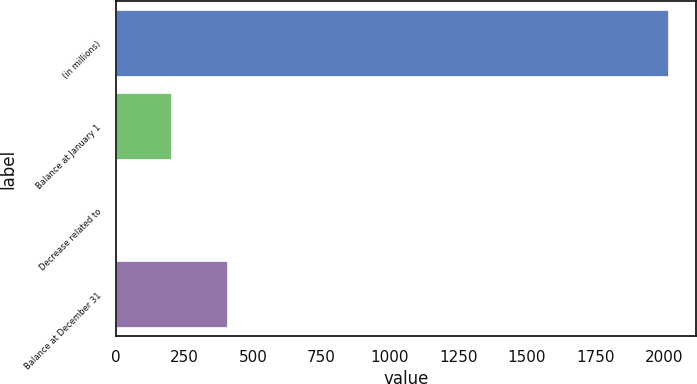Convert chart to OTSL. <chart><loc_0><loc_0><loc_500><loc_500><bar_chart><fcel>(in millions)<fcel>Balance at January 1<fcel>Decrease related to<fcel>Balance at December 31<nl><fcel>2018<fcel>205.4<fcel>4<fcel>406.8<nl></chart> 